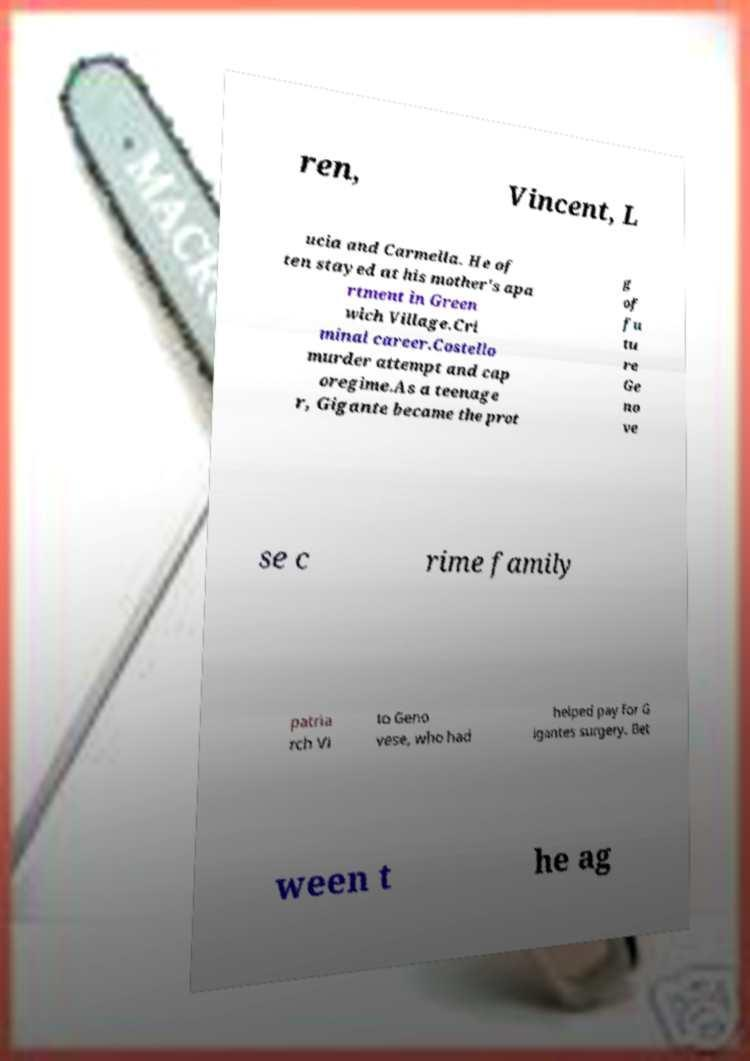Please read and relay the text visible in this image. What does it say? ren, Vincent, L ucia and Carmella. He of ten stayed at his mother's apa rtment in Green wich Village.Cri minal career.Costello murder attempt and cap oregime.As a teenage r, Gigante became the prot g of fu tu re Ge no ve se c rime family patria rch Vi to Geno vese, who had helped pay for G igantes surgery. Bet ween t he ag 